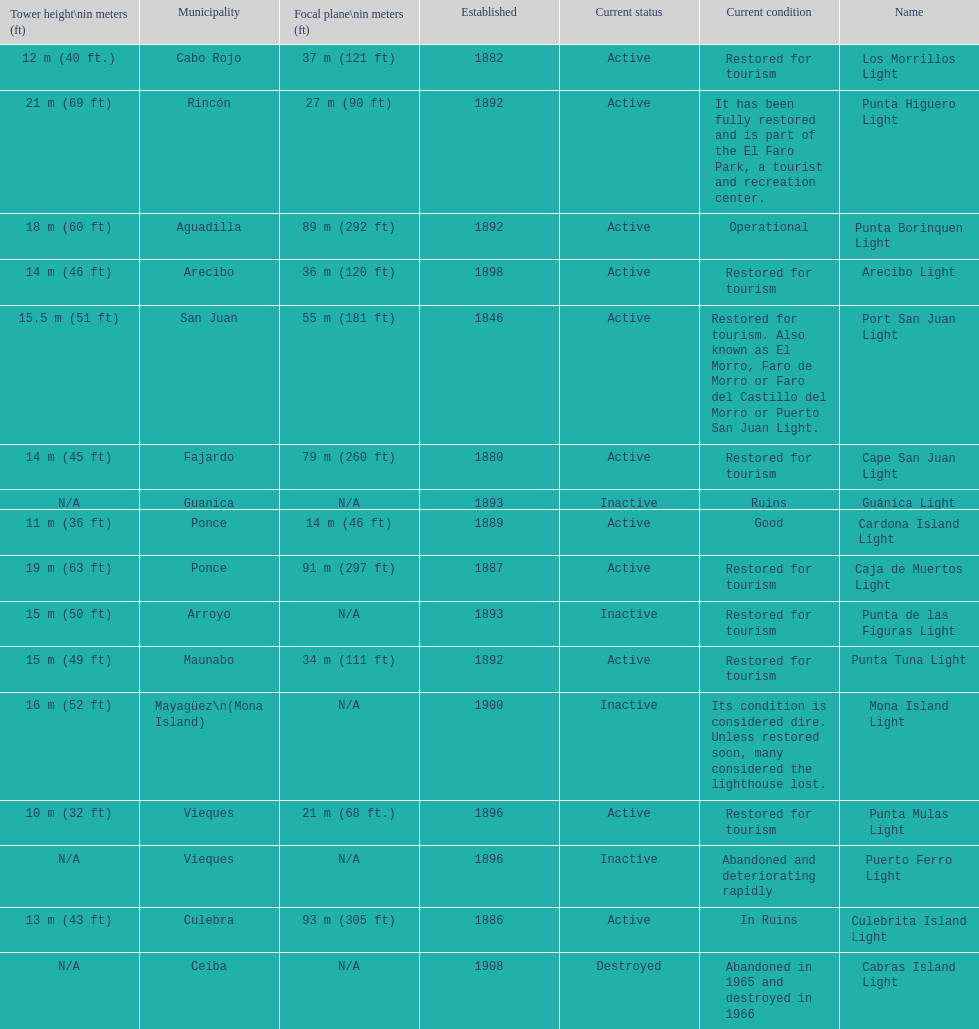Which municipality was the first to be established? San Juan. 